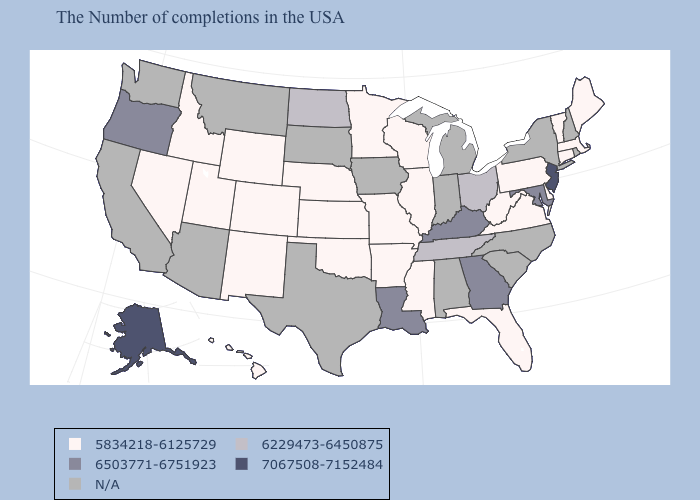Which states have the lowest value in the USA?
Write a very short answer. Maine, Massachusetts, Vermont, Connecticut, Delaware, Pennsylvania, Virginia, West Virginia, Florida, Wisconsin, Illinois, Mississippi, Missouri, Arkansas, Minnesota, Kansas, Nebraska, Oklahoma, Wyoming, Colorado, New Mexico, Utah, Idaho, Nevada, Hawaii. What is the value of New Hampshire?
Keep it brief. N/A. What is the value of Illinois?
Be succinct. 5834218-6125729. Does the first symbol in the legend represent the smallest category?
Answer briefly. Yes. Does Illinois have the highest value in the MidWest?
Give a very brief answer. No. How many symbols are there in the legend?
Short answer required. 5. Name the states that have a value in the range 5834218-6125729?
Short answer required. Maine, Massachusetts, Vermont, Connecticut, Delaware, Pennsylvania, Virginia, West Virginia, Florida, Wisconsin, Illinois, Mississippi, Missouri, Arkansas, Minnesota, Kansas, Nebraska, Oklahoma, Wyoming, Colorado, New Mexico, Utah, Idaho, Nevada, Hawaii. Which states have the highest value in the USA?
Write a very short answer. New Jersey, Alaska. What is the value of North Carolina?
Concise answer only. N/A. Does Ohio have the lowest value in the MidWest?
Be succinct. No. Does the first symbol in the legend represent the smallest category?
Short answer required. Yes. 